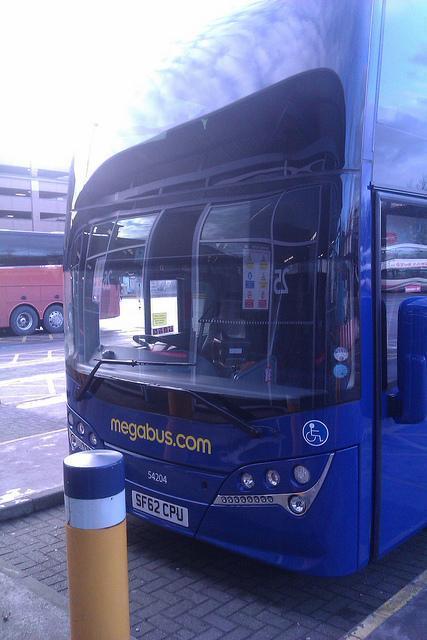How many buses are there?
Give a very brief answer. 2. 